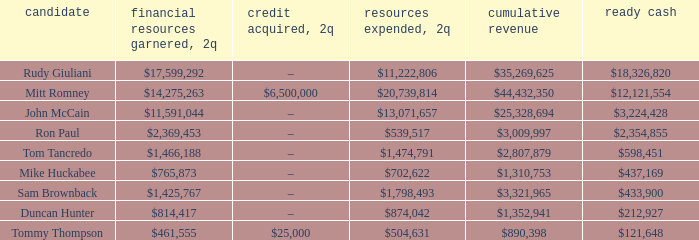When 2q expenditure takes place and 2q is equal to $874,042, how much money is generated? $814,417. 